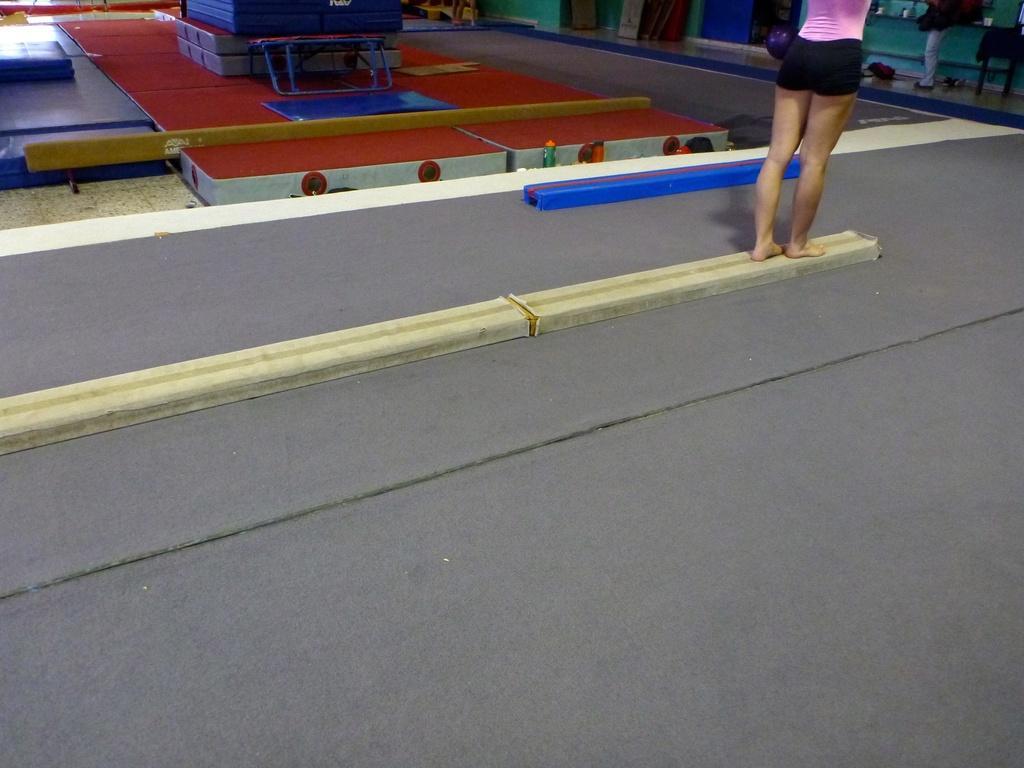Could you give a brief overview of what you see in this image? This image consists of persons leg at the top. There is carpet in the middle. There are some boxes at the top. 